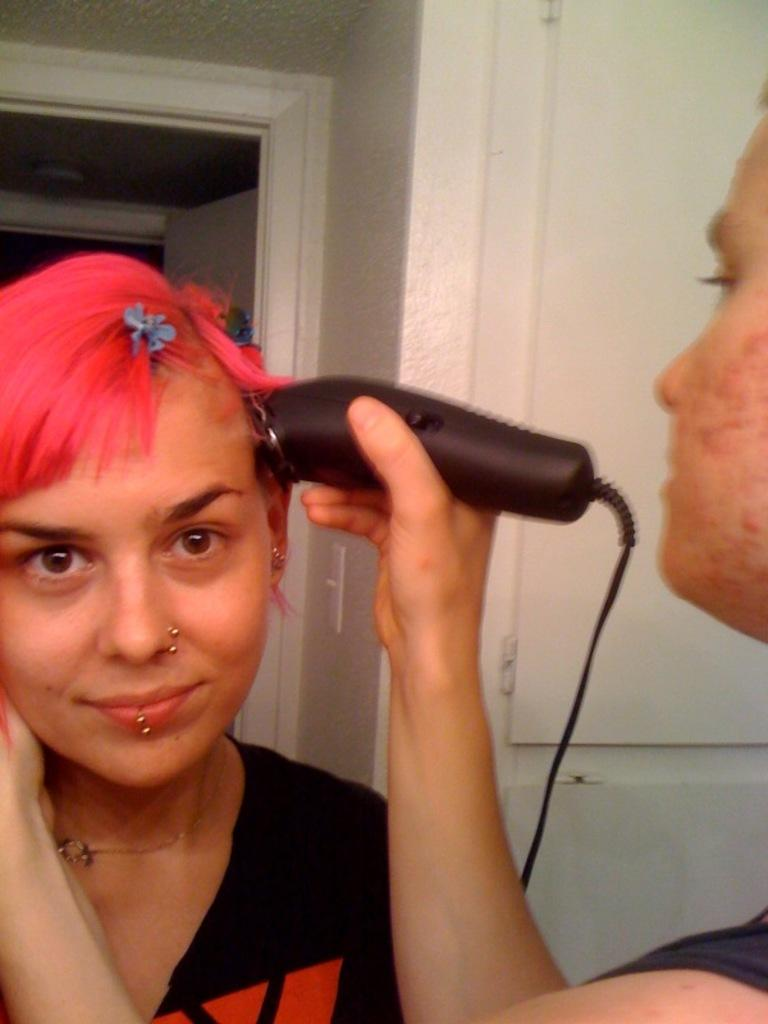How many people are present in the image? There are two people in the image. What is one person doing in the image? One person is holding an object. What can be seen in the background of the image? There is a wall in the background of the image. What type of lipstick is the person wearing in the image? There is no lipstick or any indication of a person wearing lipstick in the image. 